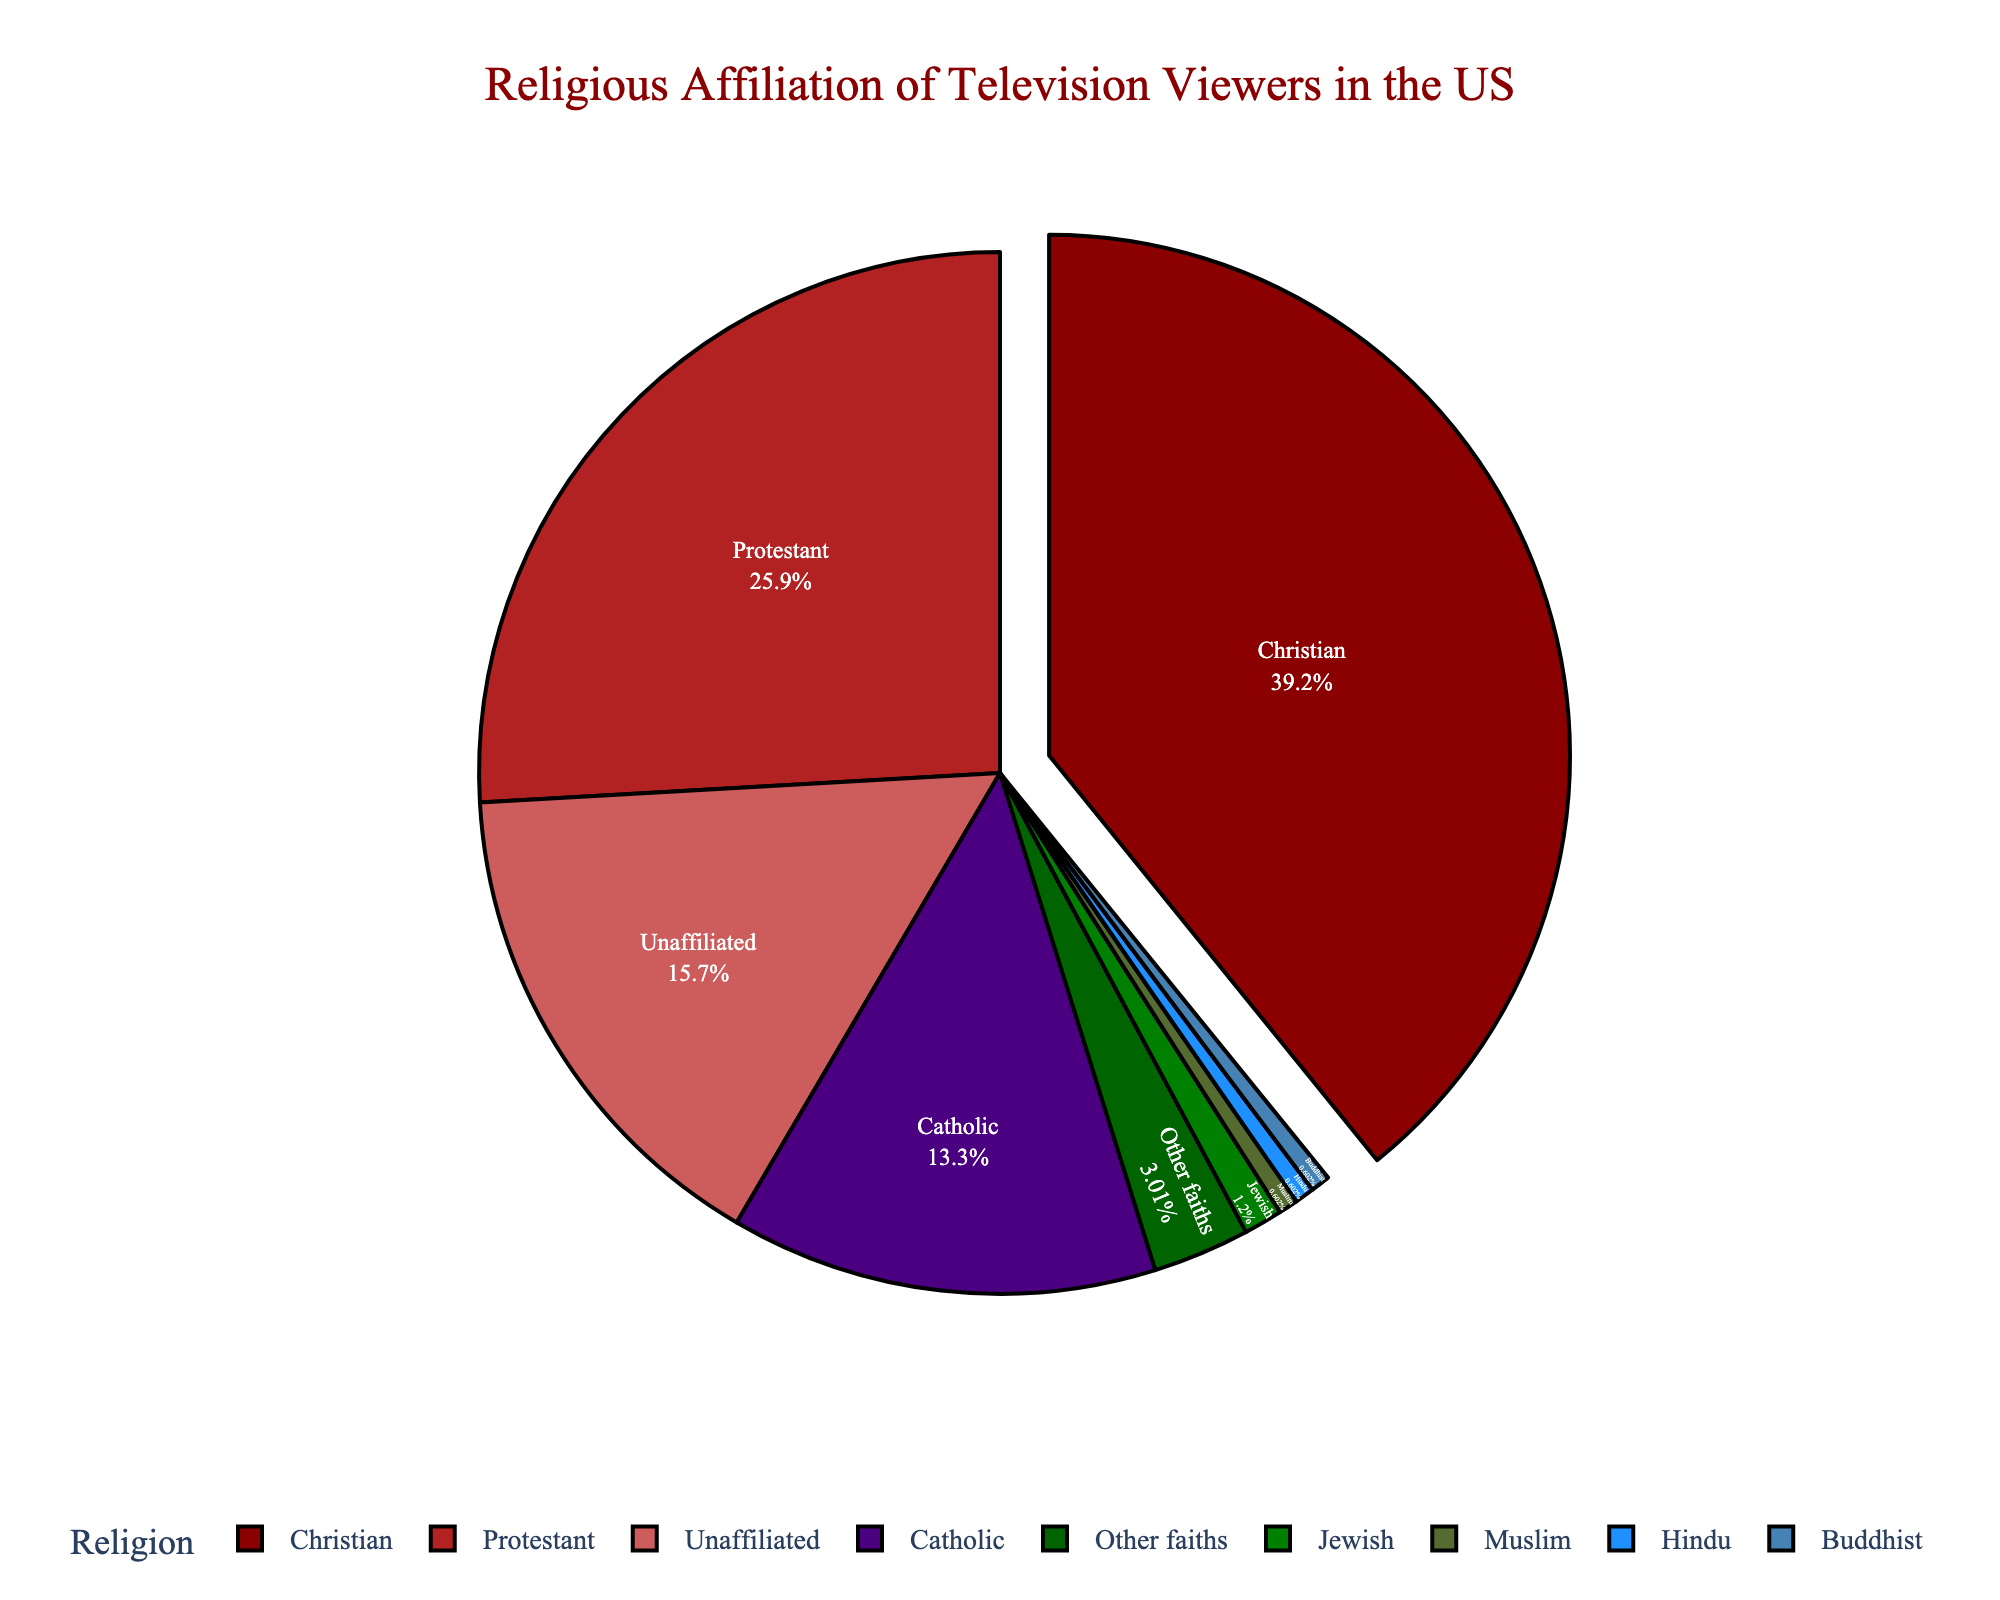What is the largest religious affiliation among television viewers in the US? The pie chart shows the percentage of each religious affiliation. The largest percentage is for Christians, which is 65%.
Answer: Christian Which two religious affiliations together make up more than 60% of television viewers? By looking at the percentage values, Christians (65%) make up more than 60% alone, so combining Christians with any other category would still exceed 60%.
Answer: Christian and any other affiliation How much larger is the percentage of Protestant viewers compared to Catholic viewers? From the pie chart, Protestant viewers constitute 43% and Catholic viewers 22%. The difference is 43% - 22% = 21%.
Answer: 21% What is the combined percentage of viewers affiliated with Jewish, Muslim, Hindu, and Buddhist religions? Add the percentages of Jewish (2%), Muslim (1%), Hindu (1%), and Buddhist (1%). So, 2% + 1% + 1% + 1% = 5%.
Answer: 5% Which religious affiliation has the second smallest percentage of television viewers? Looking at the percentages, the smallest percentage is for Muslim, Hindu, and Buddhist each at 1%. Other faiths have the next smallest percentage at 5%.
Answer: Other faiths Are there more Christian viewers or unaffiliated viewers? The pie chart shows that Christian viewers are 65% while unaffiliated viewers are 26%. 65% is greater than 26%.
Answer: Christian What percentage of viewers are affiliated with religions other than Christian, Catholic, or Protestant? Sum the percentages of Jewish (2%), Muslim (1%), Hindu (1%), Buddhist (1%), Unaffiliated (26%), and Other faiths (5%). So, 2% + 1% + 1% + 1% + 26% + 5% = 36%.
Answer: 36% How does the percentage of Protestant viewers compare to that of unaffiliated viewers? Protestants make up 43% of the viewers and unaffiliated viewers make up 26%. 43% is greater than 26%.
Answer: Greater What color represents the largest religious affiliation? The pie chart shows that the largest section representing Christians is colored in dark red.
Answer: Dark red Which religious affiliation is represented by the third-largest segment in the pie chart? The third-largest segment by percentage is for the unaffiliated group, which is 26%.
Answer: Unaffiliated 